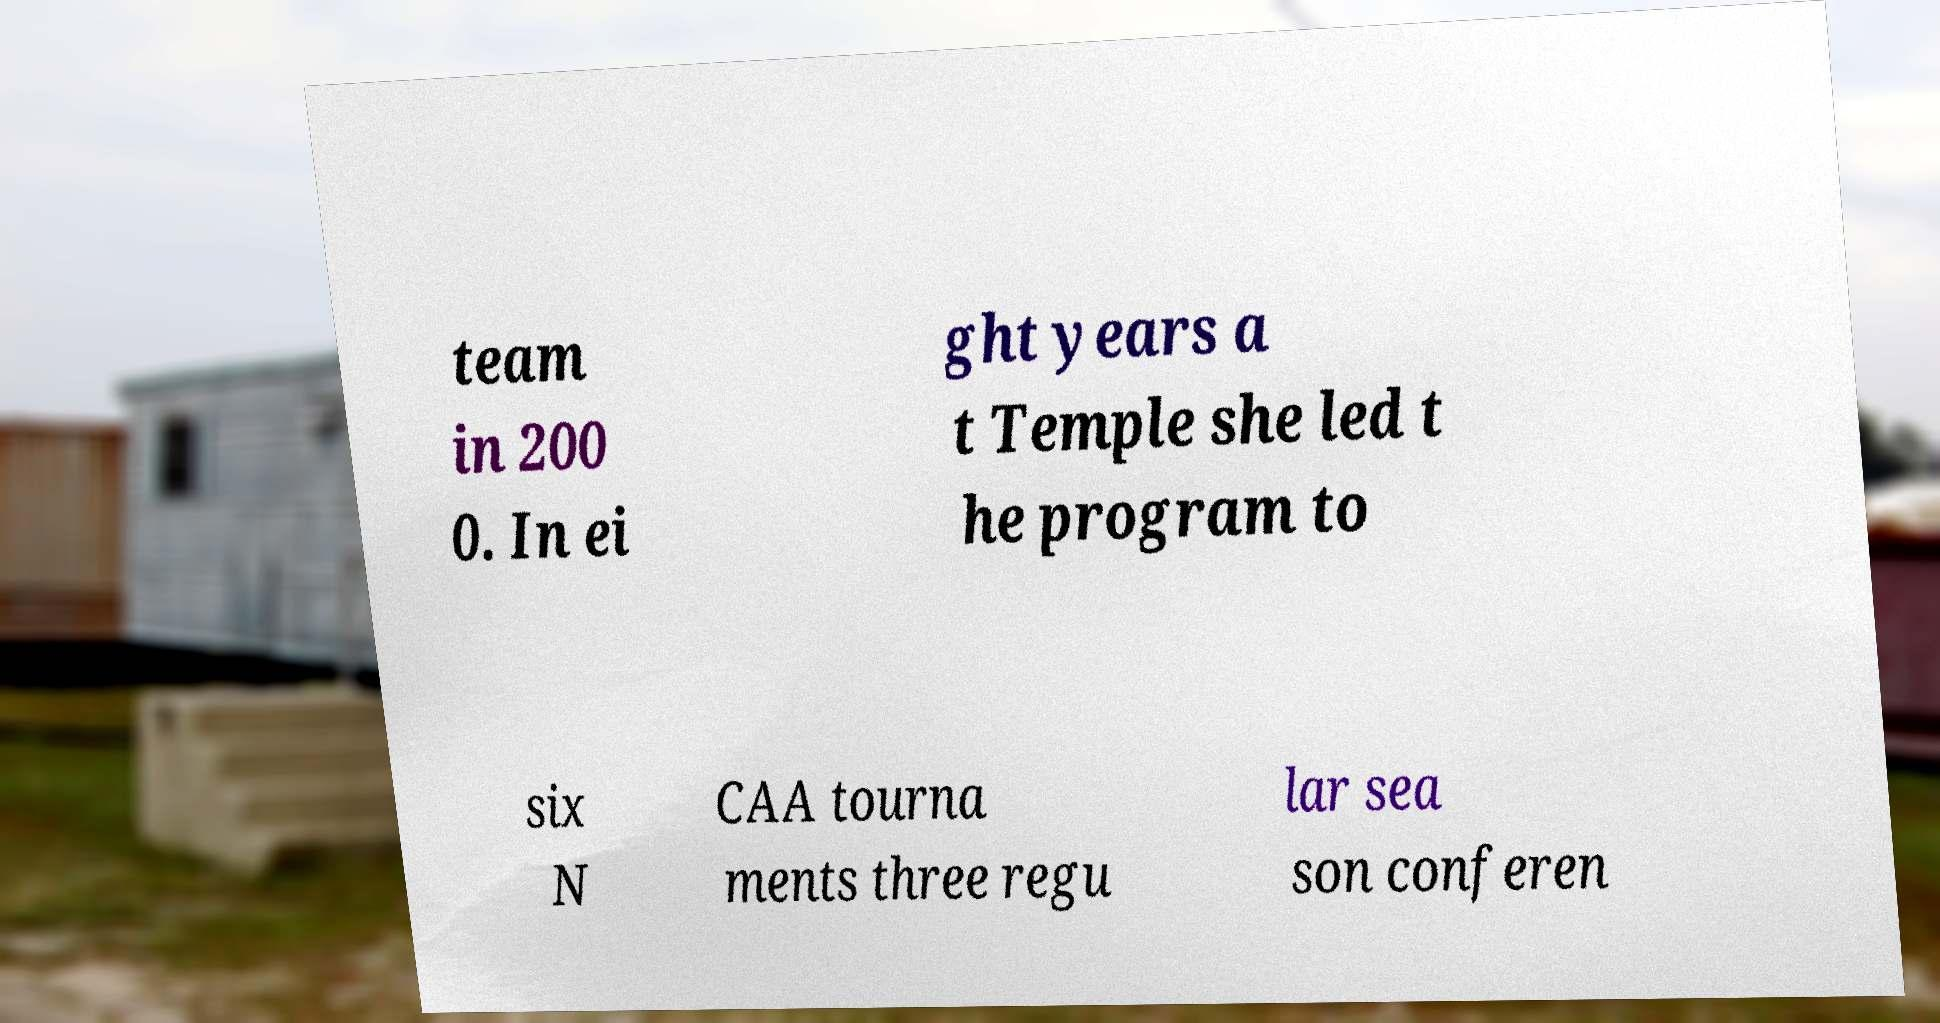I need the written content from this picture converted into text. Can you do that? team in 200 0. In ei ght years a t Temple she led t he program to six N CAA tourna ments three regu lar sea son conferen 